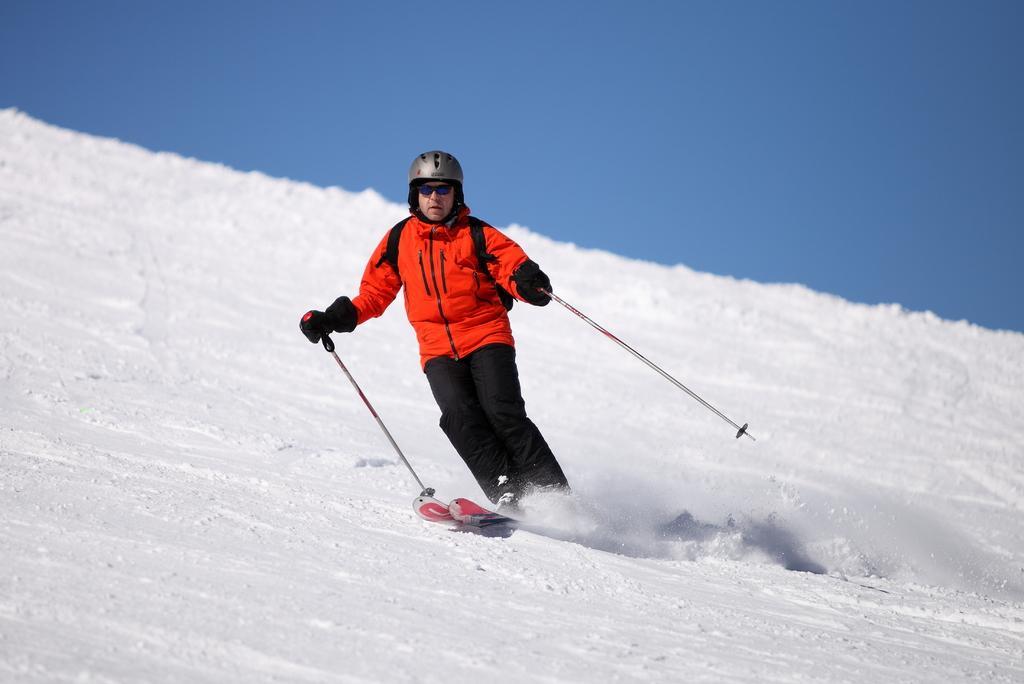Please provide a concise description of this image. In this image in the center there is one person who is holding sticks and he is on a skateboard and skating, at the bottom there is snow and at the top of the image there is sky. 